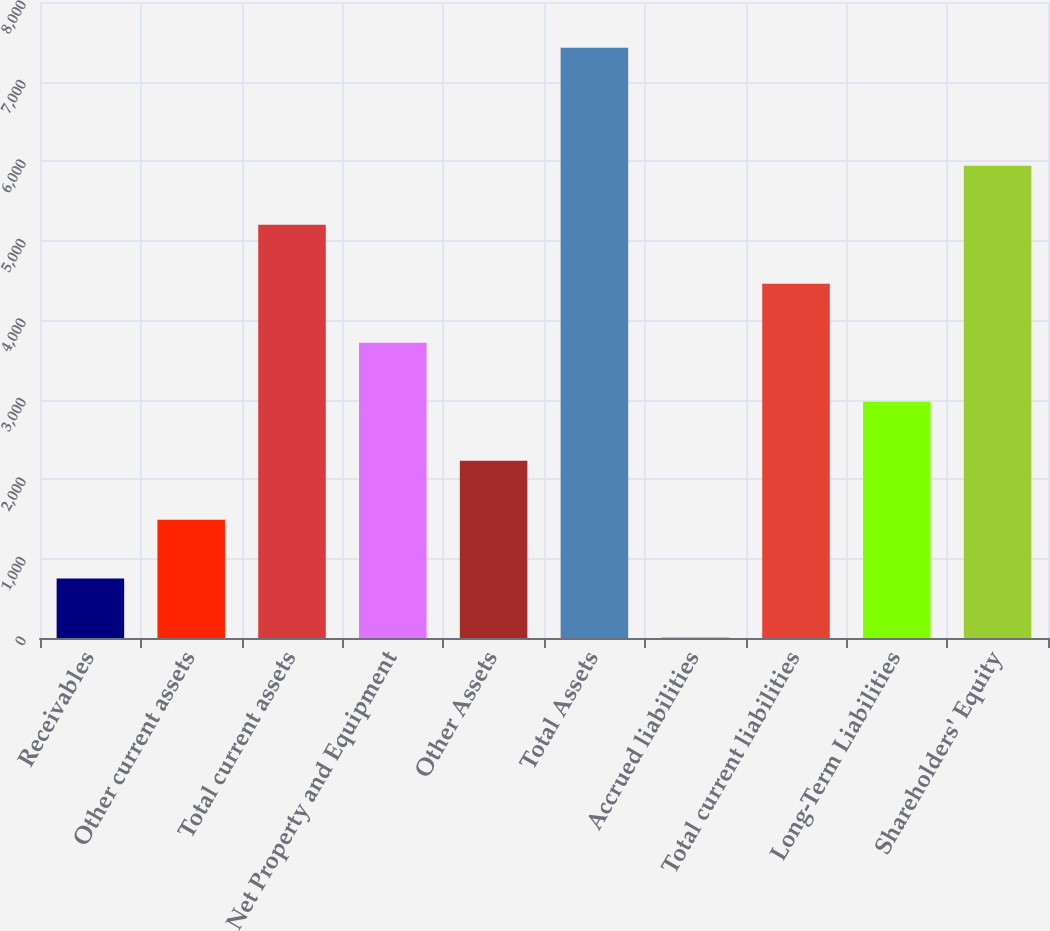Convert chart. <chart><loc_0><loc_0><loc_500><loc_500><bar_chart><fcel>Receivables<fcel>Other current assets<fcel>Total current assets<fcel>Net Property and Equipment<fcel>Other Assets<fcel>Total Assets<fcel>Accrued liabilities<fcel>Total current liabilities<fcel>Long-Term Liabilities<fcel>Shareholders' Equity<nl><fcel>746.9<fcel>1488.8<fcel>5198.3<fcel>3714.5<fcel>2230.7<fcel>7424<fcel>5<fcel>4456.4<fcel>2972.6<fcel>5940.2<nl></chart> 